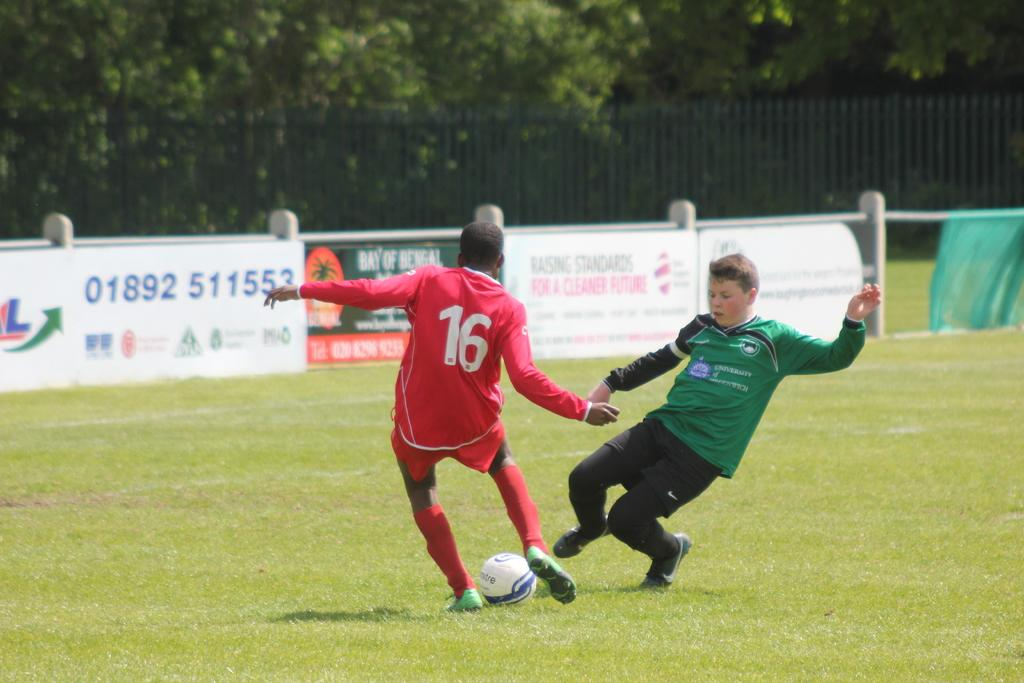What is the setting of the image? The image shows an outside view. How many people are in the image? There are two persons in the image. What are the persons wearing? The persons are wearing clothes. What activity are the persons engaged in? The persons are playing football. What can be seen in the background of the image? There is a fencing and trees in the background of the image. What type of grain is being harvested by the persons in the image? There is no grain present in the image; the persons are playing football. What is the zinc content of the soil in the image? There is no information about the soil or its zinc content in the image. 